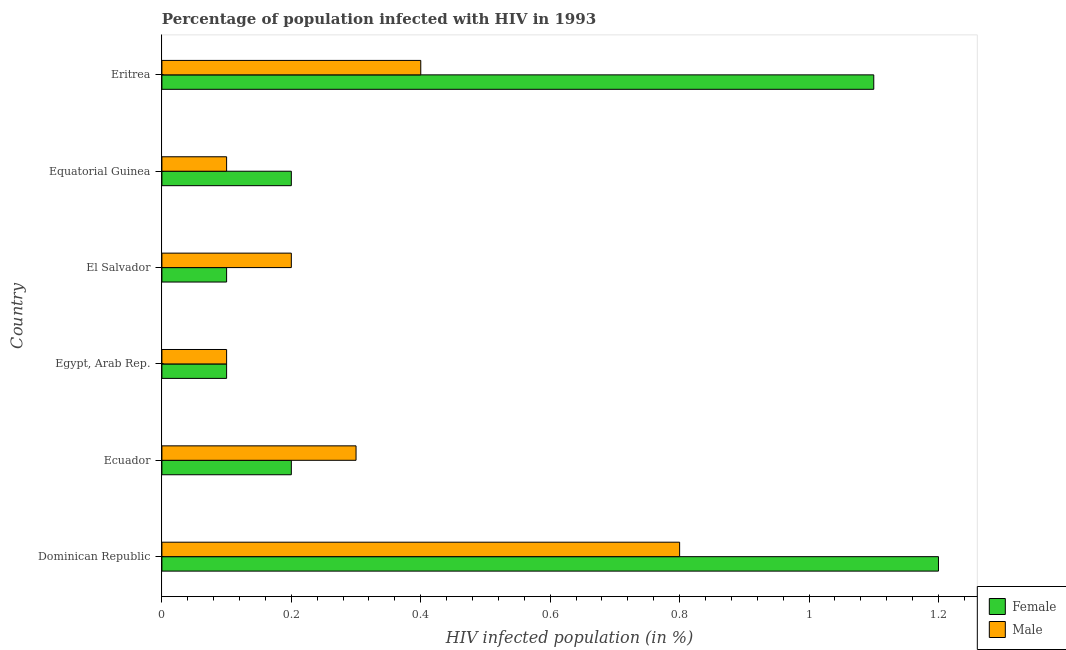How many groups of bars are there?
Your response must be concise. 6. How many bars are there on the 1st tick from the bottom?
Give a very brief answer. 2. What is the label of the 5th group of bars from the top?
Your answer should be compact. Ecuador. In how many cases, is the number of bars for a given country not equal to the number of legend labels?
Your answer should be very brief. 0. Across all countries, what is the maximum percentage of males who are infected with hiv?
Make the answer very short. 0.8. Across all countries, what is the minimum percentage of males who are infected with hiv?
Offer a terse response. 0.1. In which country was the percentage of females who are infected with hiv maximum?
Your answer should be very brief. Dominican Republic. In which country was the percentage of males who are infected with hiv minimum?
Provide a succinct answer. Egypt, Arab Rep. What is the total percentage of females who are infected with hiv in the graph?
Provide a short and direct response. 2.9. What is the difference between the percentage of females who are infected with hiv in Equatorial Guinea and the percentage of males who are infected with hiv in Dominican Republic?
Your answer should be very brief. -0.6. What is the average percentage of females who are infected with hiv per country?
Offer a very short reply. 0.48. What is the difference between the percentage of males who are infected with hiv and percentage of females who are infected with hiv in El Salvador?
Your response must be concise. 0.1. What is the ratio of the percentage of females who are infected with hiv in Egypt, Arab Rep. to that in Equatorial Guinea?
Give a very brief answer. 0.5. Is the difference between the percentage of females who are infected with hiv in Dominican Republic and Eritrea greater than the difference between the percentage of males who are infected with hiv in Dominican Republic and Eritrea?
Provide a succinct answer. No. What is the difference between the highest and the lowest percentage of females who are infected with hiv?
Give a very brief answer. 1.1. In how many countries, is the percentage of females who are infected with hiv greater than the average percentage of females who are infected with hiv taken over all countries?
Make the answer very short. 2. Is the sum of the percentage of females who are infected with hiv in Dominican Republic and Equatorial Guinea greater than the maximum percentage of males who are infected with hiv across all countries?
Provide a succinct answer. Yes. What does the 1st bar from the bottom in Eritrea represents?
Your answer should be very brief. Female. What is the difference between two consecutive major ticks on the X-axis?
Give a very brief answer. 0.2. Are the values on the major ticks of X-axis written in scientific E-notation?
Provide a short and direct response. No. Does the graph contain grids?
Your answer should be very brief. No. Where does the legend appear in the graph?
Your answer should be compact. Bottom right. How many legend labels are there?
Your answer should be very brief. 2. How are the legend labels stacked?
Offer a very short reply. Vertical. What is the title of the graph?
Offer a very short reply. Percentage of population infected with HIV in 1993. What is the label or title of the X-axis?
Ensure brevity in your answer.  HIV infected population (in %). What is the HIV infected population (in %) of Female in Ecuador?
Provide a succinct answer. 0.2. What is the HIV infected population (in %) of Female in Egypt, Arab Rep.?
Provide a succinct answer. 0.1. What is the HIV infected population (in %) in Female in El Salvador?
Offer a very short reply. 0.1. What is the HIV infected population (in %) of Male in El Salvador?
Your answer should be compact. 0.2. What is the HIV infected population (in %) of Female in Equatorial Guinea?
Make the answer very short. 0.2. What is the HIV infected population (in %) in Male in Equatorial Guinea?
Provide a short and direct response. 0.1. What is the HIV infected population (in %) of Male in Eritrea?
Offer a very short reply. 0.4. Across all countries, what is the maximum HIV infected population (in %) of Female?
Give a very brief answer. 1.2. Across all countries, what is the minimum HIV infected population (in %) in Female?
Ensure brevity in your answer.  0.1. Across all countries, what is the minimum HIV infected population (in %) in Male?
Offer a very short reply. 0.1. What is the total HIV infected population (in %) in Female in the graph?
Your answer should be compact. 2.9. What is the difference between the HIV infected population (in %) of Female in Dominican Republic and that in Ecuador?
Your answer should be very brief. 1. What is the difference between the HIV infected population (in %) in Male in Dominican Republic and that in Ecuador?
Ensure brevity in your answer.  0.5. What is the difference between the HIV infected population (in %) in Male in Dominican Republic and that in Equatorial Guinea?
Provide a succinct answer. 0.7. What is the difference between the HIV infected population (in %) in Male in Dominican Republic and that in Eritrea?
Provide a succinct answer. 0.4. What is the difference between the HIV infected population (in %) in Female in Ecuador and that in Egypt, Arab Rep.?
Your answer should be compact. 0.1. What is the difference between the HIV infected population (in %) in Female in Ecuador and that in El Salvador?
Your response must be concise. 0.1. What is the difference between the HIV infected population (in %) of Female in Ecuador and that in Eritrea?
Offer a very short reply. -0.9. What is the difference between the HIV infected population (in %) of Male in Ecuador and that in Eritrea?
Ensure brevity in your answer.  -0.1. What is the difference between the HIV infected population (in %) in Female in Egypt, Arab Rep. and that in El Salvador?
Your answer should be very brief. 0. What is the difference between the HIV infected population (in %) of Female in Egypt, Arab Rep. and that in Equatorial Guinea?
Your answer should be compact. -0.1. What is the difference between the HIV infected population (in %) in Female in El Salvador and that in Equatorial Guinea?
Your answer should be compact. -0.1. What is the difference between the HIV infected population (in %) in Female in El Salvador and that in Eritrea?
Provide a short and direct response. -1. What is the difference between the HIV infected population (in %) of Male in El Salvador and that in Eritrea?
Your answer should be compact. -0.2. What is the difference between the HIV infected population (in %) of Male in Equatorial Guinea and that in Eritrea?
Your answer should be very brief. -0.3. What is the difference between the HIV infected population (in %) in Female in Dominican Republic and the HIV infected population (in %) in Male in Equatorial Guinea?
Offer a very short reply. 1.1. What is the difference between the HIV infected population (in %) of Female in Dominican Republic and the HIV infected population (in %) of Male in Eritrea?
Your response must be concise. 0.8. What is the difference between the HIV infected population (in %) in Female in Ecuador and the HIV infected population (in %) in Male in Egypt, Arab Rep.?
Ensure brevity in your answer.  0.1. What is the difference between the HIV infected population (in %) in Female in Ecuador and the HIV infected population (in %) in Male in Equatorial Guinea?
Keep it short and to the point. 0.1. What is the difference between the HIV infected population (in %) of Female in Egypt, Arab Rep. and the HIV infected population (in %) of Male in Eritrea?
Provide a succinct answer. -0.3. What is the difference between the HIV infected population (in %) of Female in Equatorial Guinea and the HIV infected population (in %) of Male in Eritrea?
Make the answer very short. -0.2. What is the average HIV infected population (in %) of Female per country?
Provide a short and direct response. 0.48. What is the average HIV infected population (in %) in Male per country?
Offer a terse response. 0.32. What is the difference between the HIV infected population (in %) in Female and HIV infected population (in %) in Male in Dominican Republic?
Your answer should be very brief. 0.4. What is the difference between the HIV infected population (in %) of Female and HIV infected population (in %) of Male in Ecuador?
Your response must be concise. -0.1. What is the difference between the HIV infected population (in %) in Female and HIV infected population (in %) in Male in Egypt, Arab Rep.?
Provide a short and direct response. 0. What is the difference between the HIV infected population (in %) in Female and HIV infected population (in %) in Male in El Salvador?
Keep it short and to the point. -0.1. What is the difference between the HIV infected population (in %) of Female and HIV infected population (in %) of Male in Equatorial Guinea?
Give a very brief answer. 0.1. What is the difference between the HIV infected population (in %) in Female and HIV infected population (in %) in Male in Eritrea?
Provide a short and direct response. 0.7. What is the ratio of the HIV infected population (in %) of Female in Dominican Republic to that in Ecuador?
Make the answer very short. 6. What is the ratio of the HIV infected population (in %) in Male in Dominican Republic to that in Ecuador?
Your response must be concise. 2.67. What is the ratio of the HIV infected population (in %) in Female in Dominican Republic to that in Eritrea?
Make the answer very short. 1.09. What is the ratio of the HIV infected population (in %) in Male in Dominican Republic to that in Eritrea?
Make the answer very short. 2. What is the ratio of the HIV infected population (in %) of Male in Ecuador to that in El Salvador?
Provide a short and direct response. 1.5. What is the ratio of the HIV infected population (in %) in Male in Ecuador to that in Equatorial Guinea?
Ensure brevity in your answer.  3. What is the ratio of the HIV infected population (in %) in Female in Ecuador to that in Eritrea?
Ensure brevity in your answer.  0.18. What is the ratio of the HIV infected population (in %) of Male in Ecuador to that in Eritrea?
Make the answer very short. 0.75. What is the ratio of the HIV infected population (in %) of Female in Egypt, Arab Rep. to that in El Salvador?
Provide a short and direct response. 1. What is the ratio of the HIV infected population (in %) in Male in Egypt, Arab Rep. to that in El Salvador?
Your response must be concise. 0.5. What is the ratio of the HIV infected population (in %) in Female in Egypt, Arab Rep. to that in Eritrea?
Offer a very short reply. 0.09. What is the ratio of the HIV infected population (in %) in Male in Egypt, Arab Rep. to that in Eritrea?
Offer a terse response. 0.25. What is the ratio of the HIV infected population (in %) of Female in El Salvador to that in Equatorial Guinea?
Your answer should be very brief. 0.5. What is the ratio of the HIV infected population (in %) of Female in El Salvador to that in Eritrea?
Keep it short and to the point. 0.09. What is the ratio of the HIV infected population (in %) of Male in El Salvador to that in Eritrea?
Your response must be concise. 0.5. What is the ratio of the HIV infected population (in %) of Female in Equatorial Guinea to that in Eritrea?
Your response must be concise. 0.18. What is the ratio of the HIV infected population (in %) of Male in Equatorial Guinea to that in Eritrea?
Your response must be concise. 0.25. What is the difference between the highest and the second highest HIV infected population (in %) in Male?
Provide a succinct answer. 0.4. What is the difference between the highest and the lowest HIV infected population (in %) of Female?
Provide a short and direct response. 1.1. What is the difference between the highest and the lowest HIV infected population (in %) in Male?
Provide a succinct answer. 0.7. 